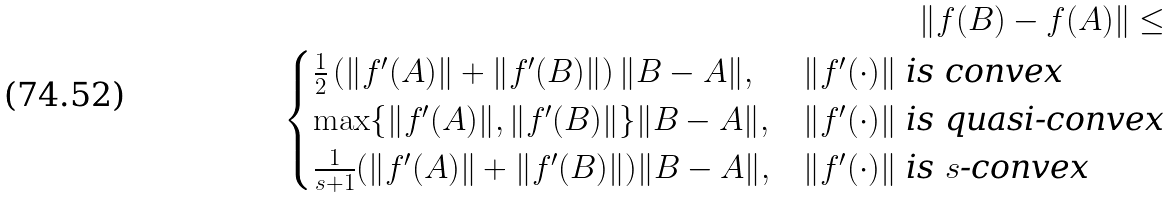<formula> <loc_0><loc_0><loc_500><loc_500>\left \| f ( B ) - f ( A ) \right \| \leq \\ \begin{cases} \frac { 1 } { 2 } \left ( \| f ^ { \prime } ( A ) \| + \| f ^ { \prime } ( B ) \| \right ) \| B - A \| , & \text {$\|f^{\prime}(\cdot)\|$ is convex} \\ \max \{ \| f ^ { \prime } ( A ) \| , \| f ^ { \prime } ( B ) \| \} \| B - A \| , & \text {$\|f^{\prime}(\cdot)\|$ is quasi-convex} \\ \frac { 1 } { s + 1 } ( \| f ^ { \prime } ( A ) \| + \| f ^ { \prime } ( B ) \| ) \| B - A \| , & \text {$\|f^{\prime}(\cdot)\|$ is $s$-convex} \end{cases}</formula> 